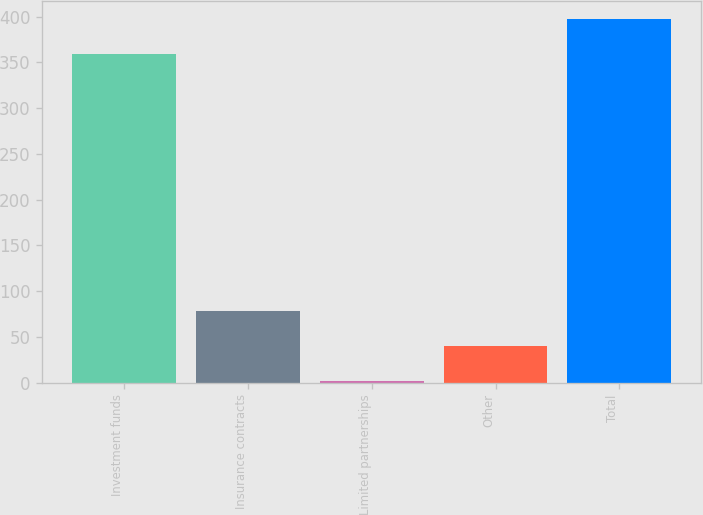Convert chart. <chart><loc_0><loc_0><loc_500><loc_500><bar_chart><fcel>Investment funds<fcel>Insurance contracts<fcel>Limited partnerships<fcel>Other<fcel>Total<nl><fcel>359.1<fcel>78.38<fcel>2.08<fcel>40.23<fcel>397.25<nl></chart> 